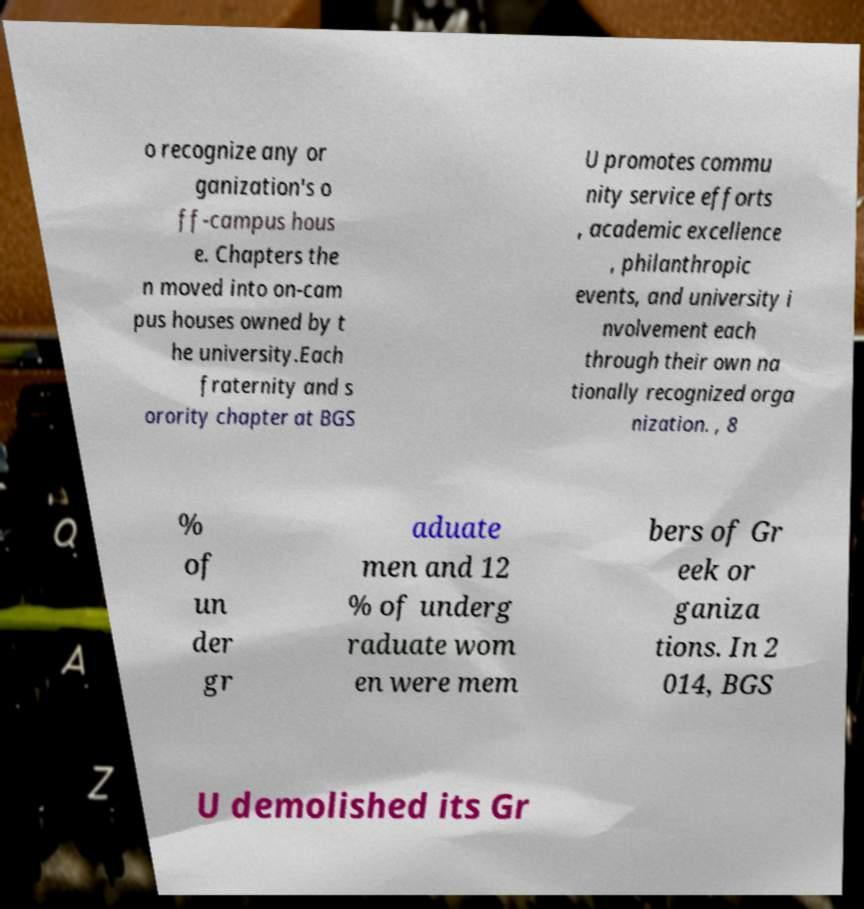Could you assist in decoding the text presented in this image and type it out clearly? o recognize any or ganization's o ff-campus hous e. Chapters the n moved into on-cam pus houses owned by t he university.Each fraternity and s orority chapter at BGS U promotes commu nity service efforts , academic excellence , philanthropic events, and university i nvolvement each through their own na tionally recognized orga nization. , 8 % of un der gr aduate men and 12 % of underg raduate wom en were mem bers of Gr eek or ganiza tions. In 2 014, BGS U demolished its Gr 